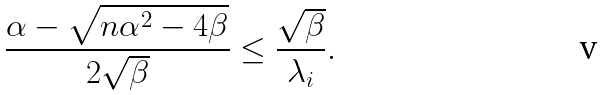<formula> <loc_0><loc_0><loc_500><loc_500>\frac { \alpha - \sqrt { n \alpha ^ { 2 } - 4 \beta } } { 2 \sqrt { \beta } } \leq \frac { \sqrt { \beta } } { \lambda _ { i } } .</formula> 